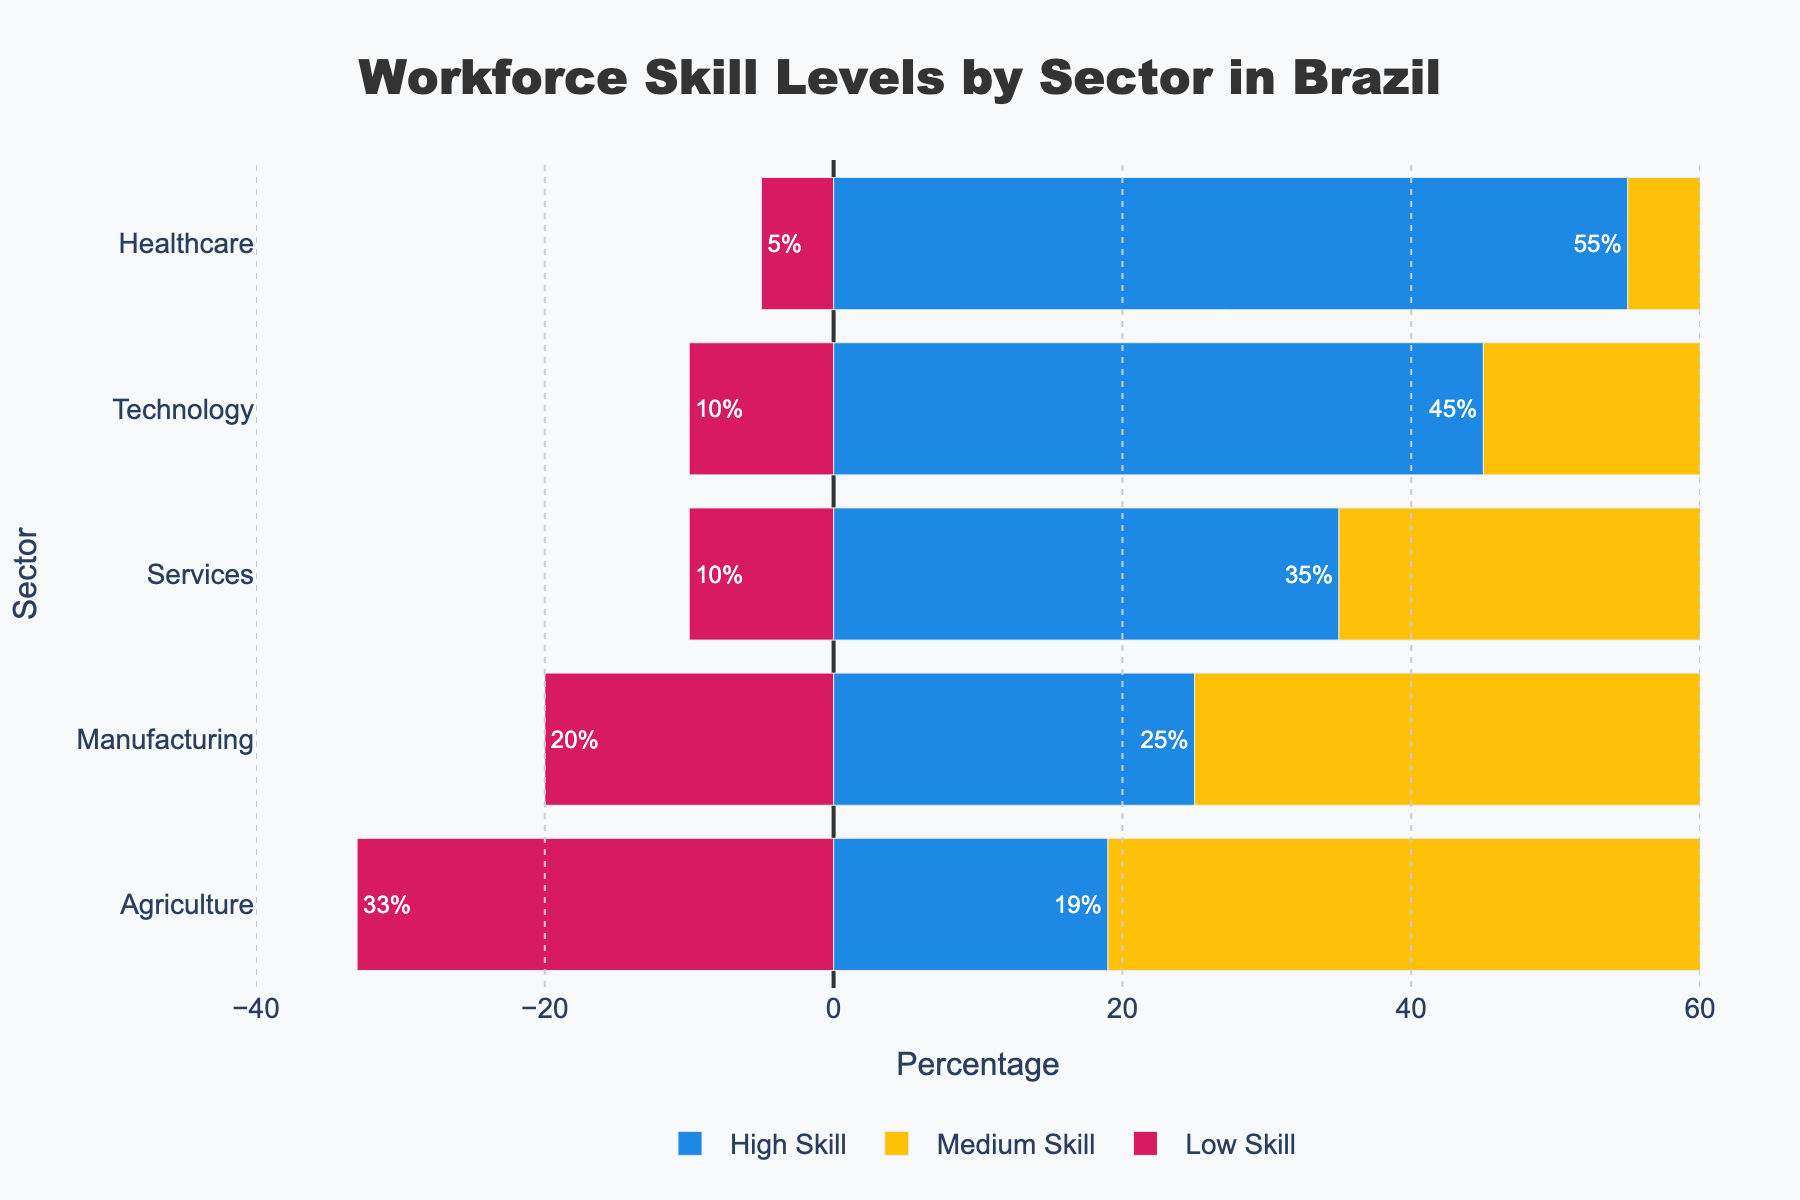What's the percentage of high-skilled workers in the Services sector? The Services sector shows two components for high-skilled workers: Postgraduate (15%) and Undergraduate (20%). Adding these percentages gives us 15% + 20% = 35%.
Answer: 35% How does the percentage of low-skilled workers in the Agriculture sector compare to the Manufacturing sector? The Agriculture sector has 33% low-skilled workers while the Manufacturing sector has 20% low-skilled workers. Thus, Agriculture has 13% more low-skilled workers than Manufacturing.
Answer: Agriculture has 13% more low-skilled workers Which sector has the highest percentage of high-skilled workers? Among the sectors, Healthcare has the highest combined percentage of high-skilled workers, with Postgraduate (30%) and Undergraduate (25%) totaling 55%. Other sectors have lower totals for high-skilled workers.
Answer: Healthcare What is the total percentage of medium-skilled workers across all sectors? To find the total, we sum the medium-skilled workers' percentages for each sector: Agriculture (30% + 18%), Manufacturing (35% + 20%), Services (40% + 15%), Technology (30% + 15%), and Healthcare (30% + 10%). This results in (48% + 55% + 55% + 45% + 40%) = 243%.
Answer: 243% Is the percentage of postgraduate workers in Technology higher than in Manufacturing? By comparing the two data points, Technology has 20% postgraduate workers and Manufacturing has 10% postgraduate workers. Hence, Technology has a higher percentage.
Answer: Yes What is the difference in the percentage of undergraduate workers between Technology and Agriculture? Technology has 25% undergraduate workers, whereas Agriculture has 12%. The difference is 25% - 12% = 13%.
Answer: 13% In which sector do medium-skilled workers form the largest group? By examining each sector, Services have the highest percentage of medium-skilled workers totaling 40% + 15% = 55%.
Answer: Services What percentage of the workforce in the Healthcare sector is either high-skilled or low-skilled? Summing the high-skilled (Postgraduate 30% and Undergraduate 25%) and low-skilled (5%) workers in Healthcare gives us (30% + 25% + 5%) = 60%.
Answer: 60% Which skill level in the Agriculture sector has the highest percentage? In the Agriculture sector, low-skilled workers have the highest percentage at 33%.
Answer: Low-skilled Among the sectors, which has the least percentage of low-skilled workers? Healthcare has the least percentage of low-skilled workers with only 5%. Other sectors have higher percentages.
Answer: Healthcare 